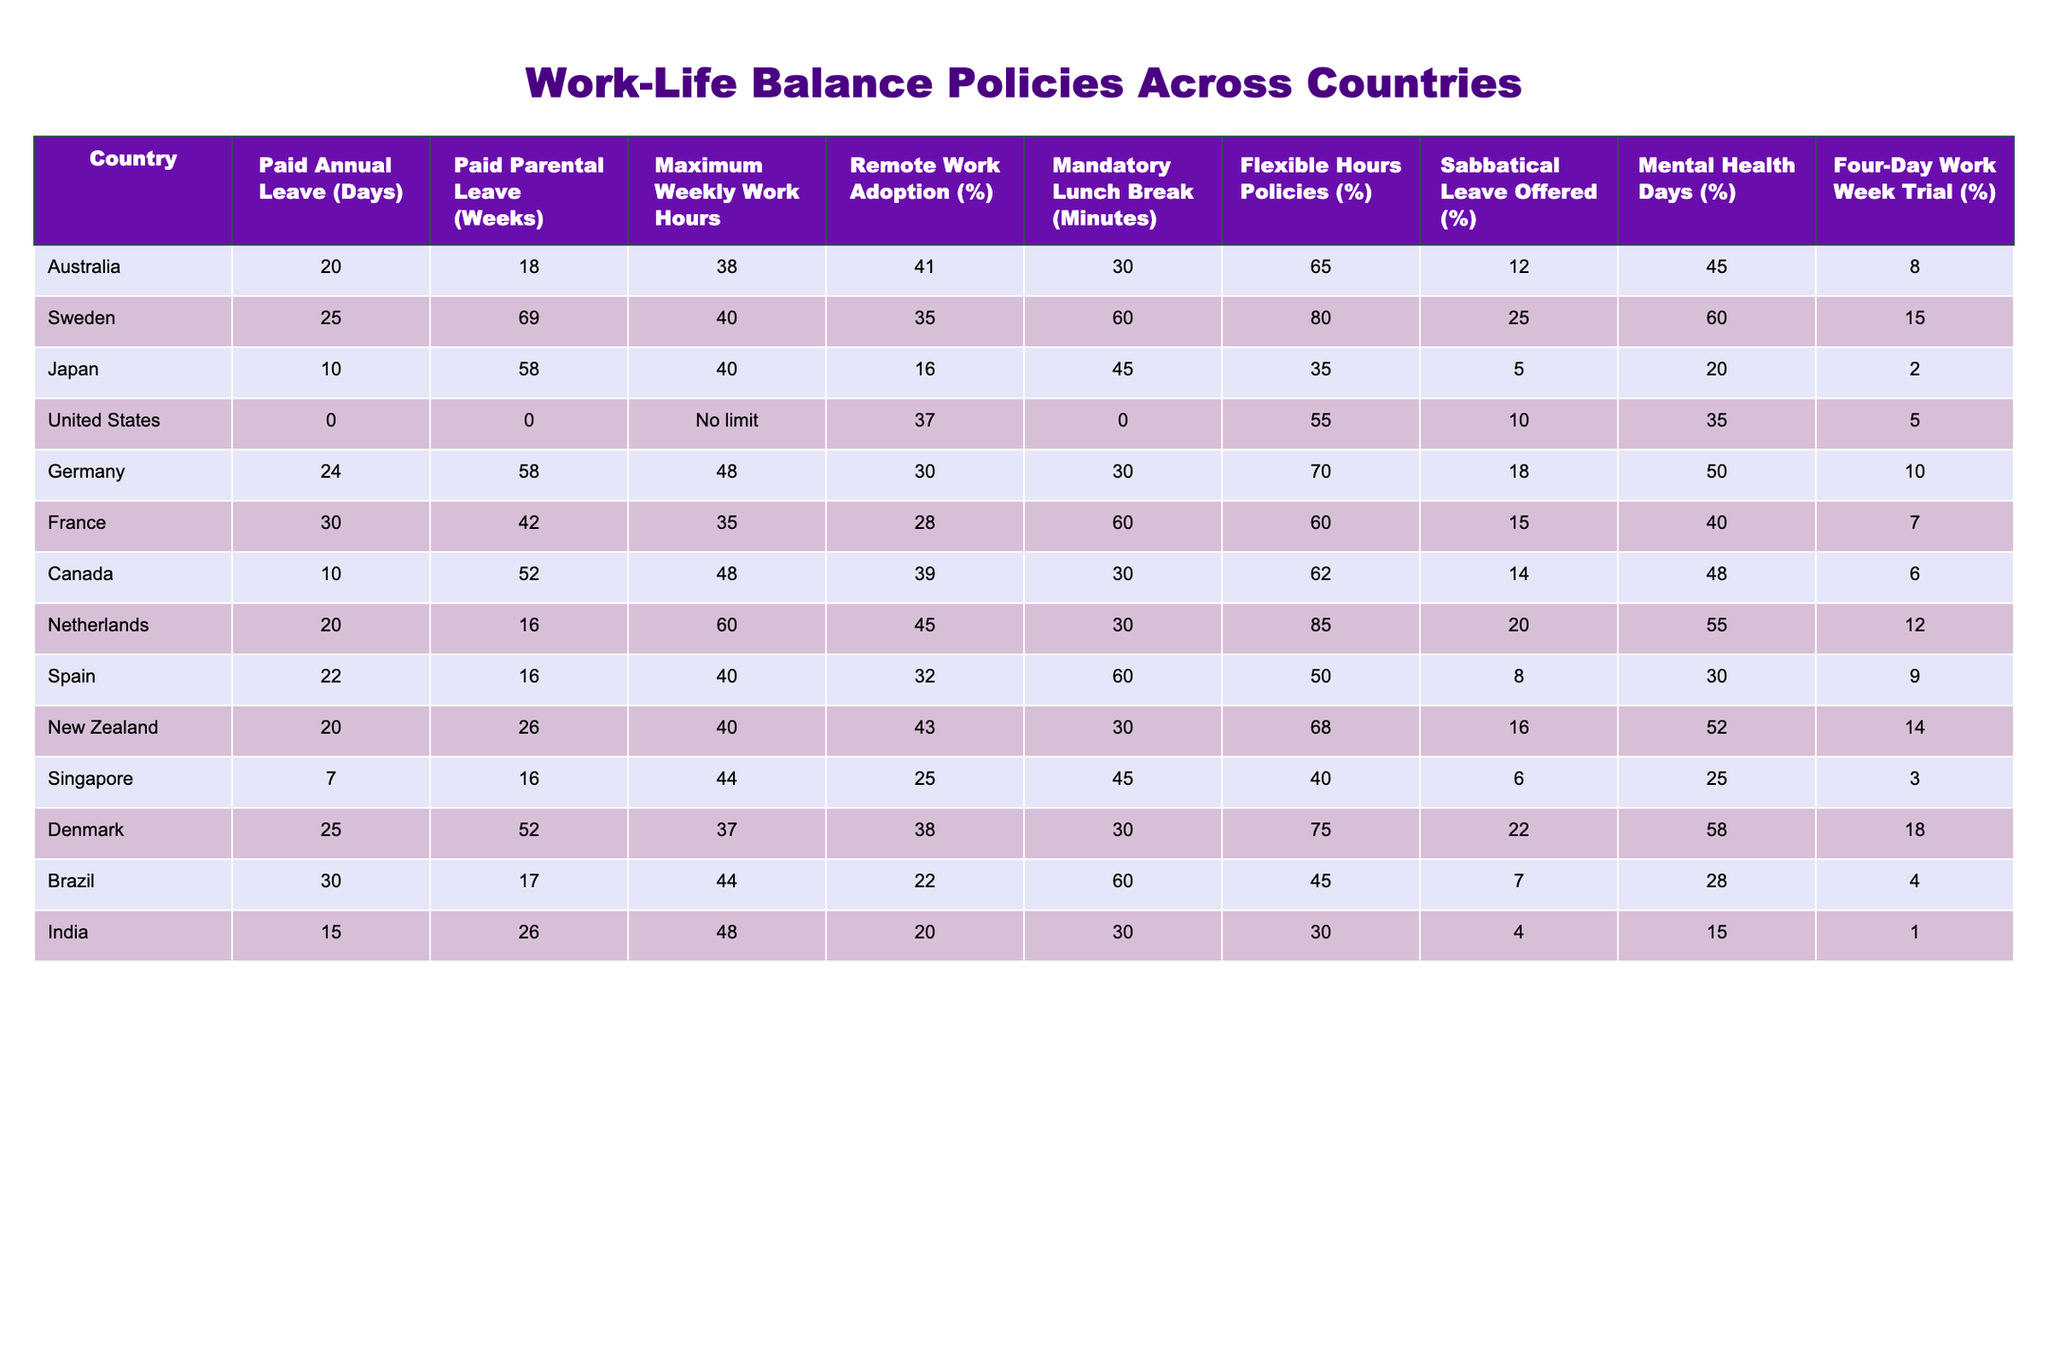What is the maximum number of paid annual leave days offered by any country? By inspecting the "Paid Annual Leave (Days)" column, the maximum value is 30 days from both Brazil and France.
Answer: 30 Which country offers the longest paid parental leave? In the "Paid Parental Leave (Weeks)" column, Sweden has the highest value of 69 weeks.
Answer: Sweden Is there any country that does not offer paid annual leave? Looking at the "Paid Annual Leave (Days)" column, the United States has a value of 0 days.
Answer: Yes What is the average maximum weekly work hours across all countries listed? To find the average, sum the maximum weekly work hours (38 + 40 + 40 + No limit + 48 + 35 + 48 + 60 + 40 + 44 + 37 + 44 + 48) and divide by the number of countries (13). Considering "No limit" as an infinite value is complex, so we exclude it and treat it as equivalent to a high value. The average works out approximately to 41.23 hours.
Answer: About 41.23 Which country has the highest percentage of remote work adoption? By checking the "Remote Work Adoption (%)" column, the Netherlands has the maximum remote work adoption rate at 85%.
Answer: Netherlands How many countries offer a four-day work week trial? From the "Four-Day Work Week Trial (%)" column, it can be seen that three countries (New Zealand, Australia, and Denmark) have their values recorded.
Answer: Three Are there any countries that offer both a flexible hours policy and a maximum of 30 minutes mandatory lunch break? Looking at both the "Flexible Hours Policies (%)" and "Mandatory Lunch Break (Minutes)" columns, Australia and Canada both offer flexible hours but have a mandatory lunch break of 30 minutes.
Answer: Yes Which country provides the least number of mental health days? In the "Mental Health Days (%)" column, Japan offers the least at 2%.
Answer: Japan Which country has a higher percentage of mental health days offered: Denmark or Canada? By comparing the "Mental Health Days (%)" values, Denmark offers 18% while Canada offers 14%. Since 18% is greater than 14%, Denmark provides more.
Answer: Denmark What is the difference in paid parental leave between Sweden and Japan? Calculate the difference by subtracting Japan’s paid parental leave (58 weeks) from Sweden’s (69 weeks). The difference is 69 - 58 = 11 weeks.
Answer: 11 weeks Which two countries offer the same amount of paid annual leave and how many days do they have? Within the "Paid Annual Leave (Days)" column, both Brazil and France offer 30 days of paid annual leave.
Answer: Brazil and France, 30 days 